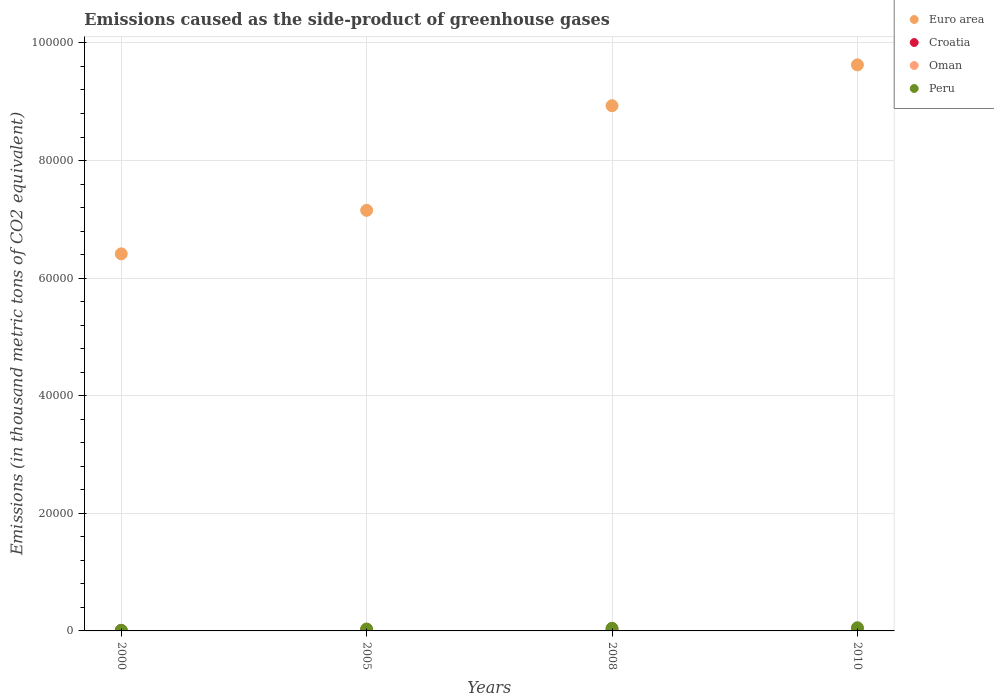What is the emissions caused as the side-product of greenhouse gases in Euro area in 2010?
Keep it short and to the point. 9.63e+04. Across all years, what is the maximum emissions caused as the side-product of greenhouse gases in Oman?
Offer a very short reply. 361. Across all years, what is the minimum emissions caused as the side-product of greenhouse gases in Peru?
Offer a very short reply. 103.1. In which year was the emissions caused as the side-product of greenhouse gases in Oman maximum?
Ensure brevity in your answer.  2010. What is the total emissions caused as the side-product of greenhouse gases in Peru in the graph?
Give a very brief answer. 1421.7. What is the difference between the emissions caused as the side-product of greenhouse gases in Croatia in 2000 and that in 2008?
Make the answer very short. 2. What is the difference between the emissions caused as the side-product of greenhouse gases in Euro area in 2005 and the emissions caused as the side-product of greenhouse gases in Croatia in 2008?
Offer a terse response. 7.15e+04. What is the average emissions caused as the side-product of greenhouse gases in Peru per year?
Your response must be concise. 355.43. In the year 2008, what is the difference between the emissions caused as the side-product of greenhouse gases in Peru and emissions caused as the side-product of greenhouse gases in Croatia?
Offer a very short reply. 374.7. In how many years, is the emissions caused as the side-product of greenhouse gases in Oman greater than 48000 thousand metric tons?
Offer a very short reply. 0. What is the ratio of the emissions caused as the side-product of greenhouse gases in Croatia in 2000 to that in 2008?
Give a very brief answer. 1.03. What is the difference between the highest and the second highest emissions caused as the side-product of greenhouse gases in Oman?
Keep it short and to the point. 94.1. What is the difference between the highest and the lowest emissions caused as the side-product of greenhouse gases in Euro area?
Give a very brief answer. 3.21e+04. In how many years, is the emissions caused as the side-product of greenhouse gases in Euro area greater than the average emissions caused as the side-product of greenhouse gases in Euro area taken over all years?
Provide a succinct answer. 2. Is it the case that in every year, the sum of the emissions caused as the side-product of greenhouse gases in Croatia and emissions caused as the side-product of greenhouse gases in Oman  is greater than the sum of emissions caused as the side-product of greenhouse gases in Peru and emissions caused as the side-product of greenhouse gases in Euro area?
Your answer should be very brief. No. Is the emissions caused as the side-product of greenhouse gases in Euro area strictly greater than the emissions caused as the side-product of greenhouse gases in Croatia over the years?
Offer a very short reply. Yes. How many dotlines are there?
Offer a very short reply. 4. How many years are there in the graph?
Keep it short and to the point. 4. What is the difference between two consecutive major ticks on the Y-axis?
Provide a succinct answer. 2.00e+04. How many legend labels are there?
Offer a very short reply. 4. What is the title of the graph?
Provide a succinct answer. Emissions caused as the side-product of greenhouse gases. What is the label or title of the X-axis?
Provide a short and direct response. Years. What is the label or title of the Y-axis?
Your answer should be compact. Emissions (in thousand metric tons of CO2 equivalent). What is the Emissions (in thousand metric tons of CO2 equivalent) in Euro area in 2000?
Offer a terse response. 6.41e+04. What is the Emissions (in thousand metric tons of CO2 equivalent) in Croatia in 2000?
Give a very brief answer. 79.3. What is the Emissions (in thousand metric tons of CO2 equivalent) of Peru in 2000?
Provide a succinct answer. 103.1. What is the Emissions (in thousand metric tons of CO2 equivalent) of Euro area in 2005?
Provide a succinct answer. 7.15e+04. What is the Emissions (in thousand metric tons of CO2 equivalent) of Croatia in 2005?
Ensure brevity in your answer.  58.4. What is the Emissions (in thousand metric tons of CO2 equivalent) in Oman in 2005?
Offer a terse response. 173.6. What is the Emissions (in thousand metric tons of CO2 equivalent) in Peru in 2005?
Provide a succinct answer. 327.6. What is the Emissions (in thousand metric tons of CO2 equivalent) of Euro area in 2008?
Ensure brevity in your answer.  8.93e+04. What is the Emissions (in thousand metric tons of CO2 equivalent) in Croatia in 2008?
Offer a very short reply. 77.3. What is the Emissions (in thousand metric tons of CO2 equivalent) in Oman in 2008?
Ensure brevity in your answer.  266.9. What is the Emissions (in thousand metric tons of CO2 equivalent) in Peru in 2008?
Offer a very short reply. 452. What is the Emissions (in thousand metric tons of CO2 equivalent) in Euro area in 2010?
Keep it short and to the point. 9.63e+04. What is the Emissions (in thousand metric tons of CO2 equivalent) in Croatia in 2010?
Your response must be concise. 89. What is the Emissions (in thousand metric tons of CO2 equivalent) in Oman in 2010?
Offer a terse response. 361. What is the Emissions (in thousand metric tons of CO2 equivalent) of Peru in 2010?
Your answer should be compact. 539. Across all years, what is the maximum Emissions (in thousand metric tons of CO2 equivalent) in Euro area?
Keep it short and to the point. 9.63e+04. Across all years, what is the maximum Emissions (in thousand metric tons of CO2 equivalent) of Croatia?
Give a very brief answer. 89. Across all years, what is the maximum Emissions (in thousand metric tons of CO2 equivalent) in Oman?
Give a very brief answer. 361. Across all years, what is the maximum Emissions (in thousand metric tons of CO2 equivalent) in Peru?
Provide a short and direct response. 539. Across all years, what is the minimum Emissions (in thousand metric tons of CO2 equivalent) of Euro area?
Keep it short and to the point. 6.41e+04. Across all years, what is the minimum Emissions (in thousand metric tons of CO2 equivalent) of Croatia?
Keep it short and to the point. 58.4. Across all years, what is the minimum Emissions (in thousand metric tons of CO2 equivalent) of Peru?
Your response must be concise. 103.1. What is the total Emissions (in thousand metric tons of CO2 equivalent) of Euro area in the graph?
Make the answer very short. 3.21e+05. What is the total Emissions (in thousand metric tons of CO2 equivalent) of Croatia in the graph?
Provide a succinct answer. 304. What is the total Emissions (in thousand metric tons of CO2 equivalent) in Oman in the graph?
Your answer should be very brief. 810.1. What is the total Emissions (in thousand metric tons of CO2 equivalent) of Peru in the graph?
Ensure brevity in your answer.  1421.7. What is the difference between the Emissions (in thousand metric tons of CO2 equivalent) of Euro area in 2000 and that in 2005?
Provide a short and direct response. -7401.3. What is the difference between the Emissions (in thousand metric tons of CO2 equivalent) of Croatia in 2000 and that in 2005?
Give a very brief answer. 20.9. What is the difference between the Emissions (in thousand metric tons of CO2 equivalent) of Oman in 2000 and that in 2005?
Ensure brevity in your answer.  -165. What is the difference between the Emissions (in thousand metric tons of CO2 equivalent) in Peru in 2000 and that in 2005?
Provide a succinct answer. -224.5. What is the difference between the Emissions (in thousand metric tons of CO2 equivalent) in Euro area in 2000 and that in 2008?
Make the answer very short. -2.52e+04. What is the difference between the Emissions (in thousand metric tons of CO2 equivalent) of Croatia in 2000 and that in 2008?
Make the answer very short. 2. What is the difference between the Emissions (in thousand metric tons of CO2 equivalent) in Oman in 2000 and that in 2008?
Your answer should be compact. -258.3. What is the difference between the Emissions (in thousand metric tons of CO2 equivalent) in Peru in 2000 and that in 2008?
Your answer should be compact. -348.9. What is the difference between the Emissions (in thousand metric tons of CO2 equivalent) of Euro area in 2000 and that in 2010?
Keep it short and to the point. -3.21e+04. What is the difference between the Emissions (in thousand metric tons of CO2 equivalent) in Croatia in 2000 and that in 2010?
Provide a succinct answer. -9.7. What is the difference between the Emissions (in thousand metric tons of CO2 equivalent) of Oman in 2000 and that in 2010?
Your response must be concise. -352.4. What is the difference between the Emissions (in thousand metric tons of CO2 equivalent) in Peru in 2000 and that in 2010?
Your answer should be compact. -435.9. What is the difference between the Emissions (in thousand metric tons of CO2 equivalent) in Euro area in 2005 and that in 2008?
Keep it short and to the point. -1.78e+04. What is the difference between the Emissions (in thousand metric tons of CO2 equivalent) of Croatia in 2005 and that in 2008?
Your answer should be very brief. -18.9. What is the difference between the Emissions (in thousand metric tons of CO2 equivalent) of Oman in 2005 and that in 2008?
Your response must be concise. -93.3. What is the difference between the Emissions (in thousand metric tons of CO2 equivalent) of Peru in 2005 and that in 2008?
Your answer should be compact. -124.4. What is the difference between the Emissions (in thousand metric tons of CO2 equivalent) of Euro area in 2005 and that in 2010?
Offer a very short reply. -2.47e+04. What is the difference between the Emissions (in thousand metric tons of CO2 equivalent) of Croatia in 2005 and that in 2010?
Keep it short and to the point. -30.6. What is the difference between the Emissions (in thousand metric tons of CO2 equivalent) in Oman in 2005 and that in 2010?
Your answer should be compact. -187.4. What is the difference between the Emissions (in thousand metric tons of CO2 equivalent) in Peru in 2005 and that in 2010?
Offer a very short reply. -211.4. What is the difference between the Emissions (in thousand metric tons of CO2 equivalent) in Euro area in 2008 and that in 2010?
Give a very brief answer. -6944.7. What is the difference between the Emissions (in thousand metric tons of CO2 equivalent) in Oman in 2008 and that in 2010?
Ensure brevity in your answer.  -94.1. What is the difference between the Emissions (in thousand metric tons of CO2 equivalent) in Peru in 2008 and that in 2010?
Give a very brief answer. -87. What is the difference between the Emissions (in thousand metric tons of CO2 equivalent) of Euro area in 2000 and the Emissions (in thousand metric tons of CO2 equivalent) of Croatia in 2005?
Offer a terse response. 6.41e+04. What is the difference between the Emissions (in thousand metric tons of CO2 equivalent) in Euro area in 2000 and the Emissions (in thousand metric tons of CO2 equivalent) in Oman in 2005?
Keep it short and to the point. 6.40e+04. What is the difference between the Emissions (in thousand metric tons of CO2 equivalent) in Euro area in 2000 and the Emissions (in thousand metric tons of CO2 equivalent) in Peru in 2005?
Your answer should be compact. 6.38e+04. What is the difference between the Emissions (in thousand metric tons of CO2 equivalent) in Croatia in 2000 and the Emissions (in thousand metric tons of CO2 equivalent) in Oman in 2005?
Offer a terse response. -94.3. What is the difference between the Emissions (in thousand metric tons of CO2 equivalent) in Croatia in 2000 and the Emissions (in thousand metric tons of CO2 equivalent) in Peru in 2005?
Keep it short and to the point. -248.3. What is the difference between the Emissions (in thousand metric tons of CO2 equivalent) of Oman in 2000 and the Emissions (in thousand metric tons of CO2 equivalent) of Peru in 2005?
Make the answer very short. -319. What is the difference between the Emissions (in thousand metric tons of CO2 equivalent) in Euro area in 2000 and the Emissions (in thousand metric tons of CO2 equivalent) in Croatia in 2008?
Your answer should be compact. 6.41e+04. What is the difference between the Emissions (in thousand metric tons of CO2 equivalent) of Euro area in 2000 and the Emissions (in thousand metric tons of CO2 equivalent) of Oman in 2008?
Your answer should be very brief. 6.39e+04. What is the difference between the Emissions (in thousand metric tons of CO2 equivalent) of Euro area in 2000 and the Emissions (in thousand metric tons of CO2 equivalent) of Peru in 2008?
Provide a short and direct response. 6.37e+04. What is the difference between the Emissions (in thousand metric tons of CO2 equivalent) in Croatia in 2000 and the Emissions (in thousand metric tons of CO2 equivalent) in Oman in 2008?
Keep it short and to the point. -187.6. What is the difference between the Emissions (in thousand metric tons of CO2 equivalent) of Croatia in 2000 and the Emissions (in thousand metric tons of CO2 equivalent) of Peru in 2008?
Provide a short and direct response. -372.7. What is the difference between the Emissions (in thousand metric tons of CO2 equivalent) in Oman in 2000 and the Emissions (in thousand metric tons of CO2 equivalent) in Peru in 2008?
Ensure brevity in your answer.  -443.4. What is the difference between the Emissions (in thousand metric tons of CO2 equivalent) of Euro area in 2000 and the Emissions (in thousand metric tons of CO2 equivalent) of Croatia in 2010?
Offer a terse response. 6.40e+04. What is the difference between the Emissions (in thousand metric tons of CO2 equivalent) of Euro area in 2000 and the Emissions (in thousand metric tons of CO2 equivalent) of Oman in 2010?
Offer a very short reply. 6.38e+04. What is the difference between the Emissions (in thousand metric tons of CO2 equivalent) in Euro area in 2000 and the Emissions (in thousand metric tons of CO2 equivalent) in Peru in 2010?
Keep it short and to the point. 6.36e+04. What is the difference between the Emissions (in thousand metric tons of CO2 equivalent) in Croatia in 2000 and the Emissions (in thousand metric tons of CO2 equivalent) in Oman in 2010?
Provide a short and direct response. -281.7. What is the difference between the Emissions (in thousand metric tons of CO2 equivalent) of Croatia in 2000 and the Emissions (in thousand metric tons of CO2 equivalent) of Peru in 2010?
Keep it short and to the point. -459.7. What is the difference between the Emissions (in thousand metric tons of CO2 equivalent) in Oman in 2000 and the Emissions (in thousand metric tons of CO2 equivalent) in Peru in 2010?
Make the answer very short. -530.4. What is the difference between the Emissions (in thousand metric tons of CO2 equivalent) of Euro area in 2005 and the Emissions (in thousand metric tons of CO2 equivalent) of Croatia in 2008?
Give a very brief answer. 7.15e+04. What is the difference between the Emissions (in thousand metric tons of CO2 equivalent) in Euro area in 2005 and the Emissions (in thousand metric tons of CO2 equivalent) in Oman in 2008?
Offer a terse response. 7.13e+04. What is the difference between the Emissions (in thousand metric tons of CO2 equivalent) in Euro area in 2005 and the Emissions (in thousand metric tons of CO2 equivalent) in Peru in 2008?
Offer a terse response. 7.11e+04. What is the difference between the Emissions (in thousand metric tons of CO2 equivalent) of Croatia in 2005 and the Emissions (in thousand metric tons of CO2 equivalent) of Oman in 2008?
Give a very brief answer. -208.5. What is the difference between the Emissions (in thousand metric tons of CO2 equivalent) of Croatia in 2005 and the Emissions (in thousand metric tons of CO2 equivalent) of Peru in 2008?
Your answer should be compact. -393.6. What is the difference between the Emissions (in thousand metric tons of CO2 equivalent) in Oman in 2005 and the Emissions (in thousand metric tons of CO2 equivalent) in Peru in 2008?
Provide a short and direct response. -278.4. What is the difference between the Emissions (in thousand metric tons of CO2 equivalent) of Euro area in 2005 and the Emissions (in thousand metric tons of CO2 equivalent) of Croatia in 2010?
Keep it short and to the point. 7.14e+04. What is the difference between the Emissions (in thousand metric tons of CO2 equivalent) of Euro area in 2005 and the Emissions (in thousand metric tons of CO2 equivalent) of Oman in 2010?
Your answer should be very brief. 7.12e+04. What is the difference between the Emissions (in thousand metric tons of CO2 equivalent) of Euro area in 2005 and the Emissions (in thousand metric tons of CO2 equivalent) of Peru in 2010?
Your answer should be very brief. 7.10e+04. What is the difference between the Emissions (in thousand metric tons of CO2 equivalent) of Croatia in 2005 and the Emissions (in thousand metric tons of CO2 equivalent) of Oman in 2010?
Make the answer very short. -302.6. What is the difference between the Emissions (in thousand metric tons of CO2 equivalent) of Croatia in 2005 and the Emissions (in thousand metric tons of CO2 equivalent) of Peru in 2010?
Keep it short and to the point. -480.6. What is the difference between the Emissions (in thousand metric tons of CO2 equivalent) in Oman in 2005 and the Emissions (in thousand metric tons of CO2 equivalent) in Peru in 2010?
Give a very brief answer. -365.4. What is the difference between the Emissions (in thousand metric tons of CO2 equivalent) of Euro area in 2008 and the Emissions (in thousand metric tons of CO2 equivalent) of Croatia in 2010?
Give a very brief answer. 8.92e+04. What is the difference between the Emissions (in thousand metric tons of CO2 equivalent) in Euro area in 2008 and the Emissions (in thousand metric tons of CO2 equivalent) in Oman in 2010?
Make the answer very short. 8.90e+04. What is the difference between the Emissions (in thousand metric tons of CO2 equivalent) in Euro area in 2008 and the Emissions (in thousand metric tons of CO2 equivalent) in Peru in 2010?
Your answer should be very brief. 8.88e+04. What is the difference between the Emissions (in thousand metric tons of CO2 equivalent) of Croatia in 2008 and the Emissions (in thousand metric tons of CO2 equivalent) of Oman in 2010?
Offer a very short reply. -283.7. What is the difference between the Emissions (in thousand metric tons of CO2 equivalent) in Croatia in 2008 and the Emissions (in thousand metric tons of CO2 equivalent) in Peru in 2010?
Your answer should be compact. -461.7. What is the difference between the Emissions (in thousand metric tons of CO2 equivalent) in Oman in 2008 and the Emissions (in thousand metric tons of CO2 equivalent) in Peru in 2010?
Your answer should be compact. -272.1. What is the average Emissions (in thousand metric tons of CO2 equivalent) of Euro area per year?
Provide a short and direct response. 8.03e+04. What is the average Emissions (in thousand metric tons of CO2 equivalent) of Croatia per year?
Provide a succinct answer. 76. What is the average Emissions (in thousand metric tons of CO2 equivalent) in Oman per year?
Make the answer very short. 202.53. What is the average Emissions (in thousand metric tons of CO2 equivalent) of Peru per year?
Give a very brief answer. 355.43. In the year 2000, what is the difference between the Emissions (in thousand metric tons of CO2 equivalent) in Euro area and Emissions (in thousand metric tons of CO2 equivalent) in Croatia?
Ensure brevity in your answer.  6.41e+04. In the year 2000, what is the difference between the Emissions (in thousand metric tons of CO2 equivalent) of Euro area and Emissions (in thousand metric tons of CO2 equivalent) of Oman?
Provide a short and direct response. 6.41e+04. In the year 2000, what is the difference between the Emissions (in thousand metric tons of CO2 equivalent) of Euro area and Emissions (in thousand metric tons of CO2 equivalent) of Peru?
Your response must be concise. 6.40e+04. In the year 2000, what is the difference between the Emissions (in thousand metric tons of CO2 equivalent) of Croatia and Emissions (in thousand metric tons of CO2 equivalent) of Oman?
Keep it short and to the point. 70.7. In the year 2000, what is the difference between the Emissions (in thousand metric tons of CO2 equivalent) of Croatia and Emissions (in thousand metric tons of CO2 equivalent) of Peru?
Provide a short and direct response. -23.8. In the year 2000, what is the difference between the Emissions (in thousand metric tons of CO2 equivalent) of Oman and Emissions (in thousand metric tons of CO2 equivalent) of Peru?
Your answer should be very brief. -94.5. In the year 2005, what is the difference between the Emissions (in thousand metric tons of CO2 equivalent) in Euro area and Emissions (in thousand metric tons of CO2 equivalent) in Croatia?
Provide a short and direct response. 7.15e+04. In the year 2005, what is the difference between the Emissions (in thousand metric tons of CO2 equivalent) of Euro area and Emissions (in thousand metric tons of CO2 equivalent) of Oman?
Keep it short and to the point. 7.14e+04. In the year 2005, what is the difference between the Emissions (in thousand metric tons of CO2 equivalent) in Euro area and Emissions (in thousand metric tons of CO2 equivalent) in Peru?
Make the answer very short. 7.12e+04. In the year 2005, what is the difference between the Emissions (in thousand metric tons of CO2 equivalent) of Croatia and Emissions (in thousand metric tons of CO2 equivalent) of Oman?
Your response must be concise. -115.2. In the year 2005, what is the difference between the Emissions (in thousand metric tons of CO2 equivalent) of Croatia and Emissions (in thousand metric tons of CO2 equivalent) of Peru?
Make the answer very short. -269.2. In the year 2005, what is the difference between the Emissions (in thousand metric tons of CO2 equivalent) of Oman and Emissions (in thousand metric tons of CO2 equivalent) of Peru?
Provide a succinct answer. -154. In the year 2008, what is the difference between the Emissions (in thousand metric tons of CO2 equivalent) in Euro area and Emissions (in thousand metric tons of CO2 equivalent) in Croatia?
Offer a very short reply. 8.92e+04. In the year 2008, what is the difference between the Emissions (in thousand metric tons of CO2 equivalent) of Euro area and Emissions (in thousand metric tons of CO2 equivalent) of Oman?
Your response must be concise. 8.91e+04. In the year 2008, what is the difference between the Emissions (in thousand metric tons of CO2 equivalent) in Euro area and Emissions (in thousand metric tons of CO2 equivalent) in Peru?
Provide a succinct answer. 8.89e+04. In the year 2008, what is the difference between the Emissions (in thousand metric tons of CO2 equivalent) of Croatia and Emissions (in thousand metric tons of CO2 equivalent) of Oman?
Your answer should be very brief. -189.6. In the year 2008, what is the difference between the Emissions (in thousand metric tons of CO2 equivalent) in Croatia and Emissions (in thousand metric tons of CO2 equivalent) in Peru?
Offer a very short reply. -374.7. In the year 2008, what is the difference between the Emissions (in thousand metric tons of CO2 equivalent) of Oman and Emissions (in thousand metric tons of CO2 equivalent) of Peru?
Your answer should be compact. -185.1. In the year 2010, what is the difference between the Emissions (in thousand metric tons of CO2 equivalent) in Euro area and Emissions (in thousand metric tons of CO2 equivalent) in Croatia?
Give a very brief answer. 9.62e+04. In the year 2010, what is the difference between the Emissions (in thousand metric tons of CO2 equivalent) of Euro area and Emissions (in thousand metric tons of CO2 equivalent) of Oman?
Give a very brief answer. 9.59e+04. In the year 2010, what is the difference between the Emissions (in thousand metric tons of CO2 equivalent) of Euro area and Emissions (in thousand metric tons of CO2 equivalent) of Peru?
Offer a very short reply. 9.57e+04. In the year 2010, what is the difference between the Emissions (in thousand metric tons of CO2 equivalent) of Croatia and Emissions (in thousand metric tons of CO2 equivalent) of Oman?
Provide a succinct answer. -272. In the year 2010, what is the difference between the Emissions (in thousand metric tons of CO2 equivalent) in Croatia and Emissions (in thousand metric tons of CO2 equivalent) in Peru?
Your response must be concise. -450. In the year 2010, what is the difference between the Emissions (in thousand metric tons of CO2 equivalent) of Oman and Emissions (in thousand metric tons of CO2 equivalent) of Peru?
Offer a terse response. -178. What is the ratio of the Emissions (in thousand metric tons of CO2 equivalent) in Euro area in 2000 to that in 2005?
Provide a succinct answer. 0.9. What is the ratio of the Emissions (in thousand metric tons of CO2 equivalent) in Croatia in 2000 to that in 2005?
Provide a short and direct response. 1.36. What is the ratio of the Emissions (in thousand metric tons of CO2 equivalent) of Oman in 2000 to that in 2005?
Offer a very short reply. 0.05. What is the ratio of the Emissions (in thousand metric tons of CO2 equivalent) in Peru in 2000 to that in 2005?
Your response must be concise. 0.31. What is the ratio of the Emissions (in thousand metric tons of CO2 equivalent) of Euro area in 2000 to that in 2008?
Your answer should be very brief. 0.72. What is the ratio of the Emissions (in thousand metric tons of CO2 equivalent) of Croatia in 2000 to that in 2008?
Your response must be concise. 1.03. What is the ratio of the Emissions (in thousand metric tons of CO2 equivalent) in Oman in 2000 to that in 2008?
Offer a very short reply. 0.03. What is the ratio of the Emissions (in thousand metric tons of CO2 equivalent) of Peru in 2000 to that in 2008?
Offer a very short reply. 0.23. What is the ratio of the Emissions (in thousand metric tons of CO2 equivalent) in Euro area in 2000 to that in 2010?
Ensure brevity in your answer.  0.67. What is the ratio of the Emissions (in thousand metric tons of CO2 equivalent) in Croatia in 2000 to that in 2010?
Make the answer very short. 0.89. What is the ratio of the Emissions (in thousand metric tons of CO2 equivalent) in Oman in 2000 to that in 2010?
Offer a terse response. 0.02. What is the ratio of the Emissions (in thousand metric tons of CO2 equivalent) of Peru in 2000 to that in 2010?
Provide a short and direct response. 0.19. What is the ratio of the Emissions (in thousand metric tons of CO2 equivalent) of Euro area in 2005 to that in 2008?
Provide a short and direct response. 0.8. What is the ratio of the Emissions (in thousand metric tons of CO2 equivalent) of Croatia in 2005 to that in 2008?
Your answer should be very brief. 0.76. What is the ratio of the Emissions (in thousand metric tons of CO2 equivalent) in Oman in 2005 to that in 2008?
Keep it short and to the point. 0.65. What is the ratio of the Emissions (in thousand metric tons of CO2 equivalent) of Peru in 2005 to that in 2008?
Ensure brevity in your answer.  0.72. What is the ratio of the Emissions (in thousand metric tons of CO2 equivalent) in Euro area in 2005 to that in 2010?
Keep it short and to the point. 0.74. What is the ratio of the Emissions (in thousand metric tons of CO2 equivalent) in Croatia in 2005 to that in 2010?
Keep it short and to the point. 0.66. What is the ratio of the Emissions (in thousand metric tons of CO2 equivalent) of Oman in 2005 to that in 2010?
Your answer should be very brief. 0.48. What is the ratio of the Emissions (in thousand metric tons of CO2 equivalent) in Peru in 2005 to that in 2010?
Give a very brief answer. 0.61. What is the ratio of the Emissions (in thousand metric tons of CO2 equivalent) of Euro area in 2008 to that in 2010?
Give a very brief answer. 0.93. What is the ratio of the Emissions (in thousand metric tons of CO2 equivalent) in Croatia in 2008 to that in 2010?
Keep it short and to the point. 0.87. What is the ratio of the Emissions (in thousand metric tons of CO2 equivalent) in Oman in 2008 to that in 2010?
Your response must be concise. 0.74. What is the ratio of the Emissions (in thousand metric tons of CO2 equivalent) of Peru in 2008 to that in 2010?
Keep it short and to the point. 0.84. What is the difference between the highest and the second highest Emissions (in thousand metric tons of CO2 equivalent) in Euro area?
Your answer should be compact. 6944.7. What is the difference between the highest and the second highest Emissions (in thousand metric tons of CO2 equivalent) in Oman?
Offer a very short reply. 94.1. What is the difference between the highest and the lowest Emissions (in thousand metric tons of CO2 equivalent) in Euro area?
Give a very brief answer. 3.21e+04. What is the difference between the highest and the lowest Emissions (in thousand metric tons of CO2 equivalent) in Croatia?
Ensure brevity in your answer.  30.6. What is the difference between the highest and the lowest Emissions (in thousand metric tons of CO2 equivalent) in Oman?
Your response must be concise. 352.4. What is the difference between the highest and the lowest Emissions (in thousand metric tons of CO2 equivalent) in Peru?
Provide a succinct answer. 435.9. 